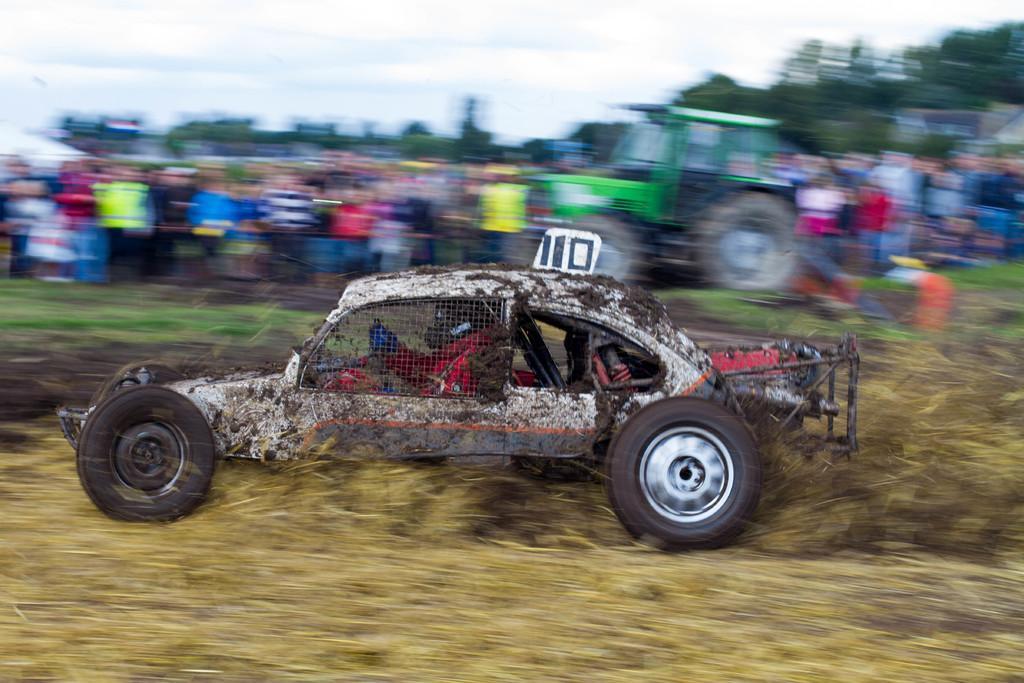Could you give a brief overview of what you see in this image? In the image we can see a vehicle and in the vehicle there is a person sitting, this is a dry grass, tree and a sky. There is a blurred background. 